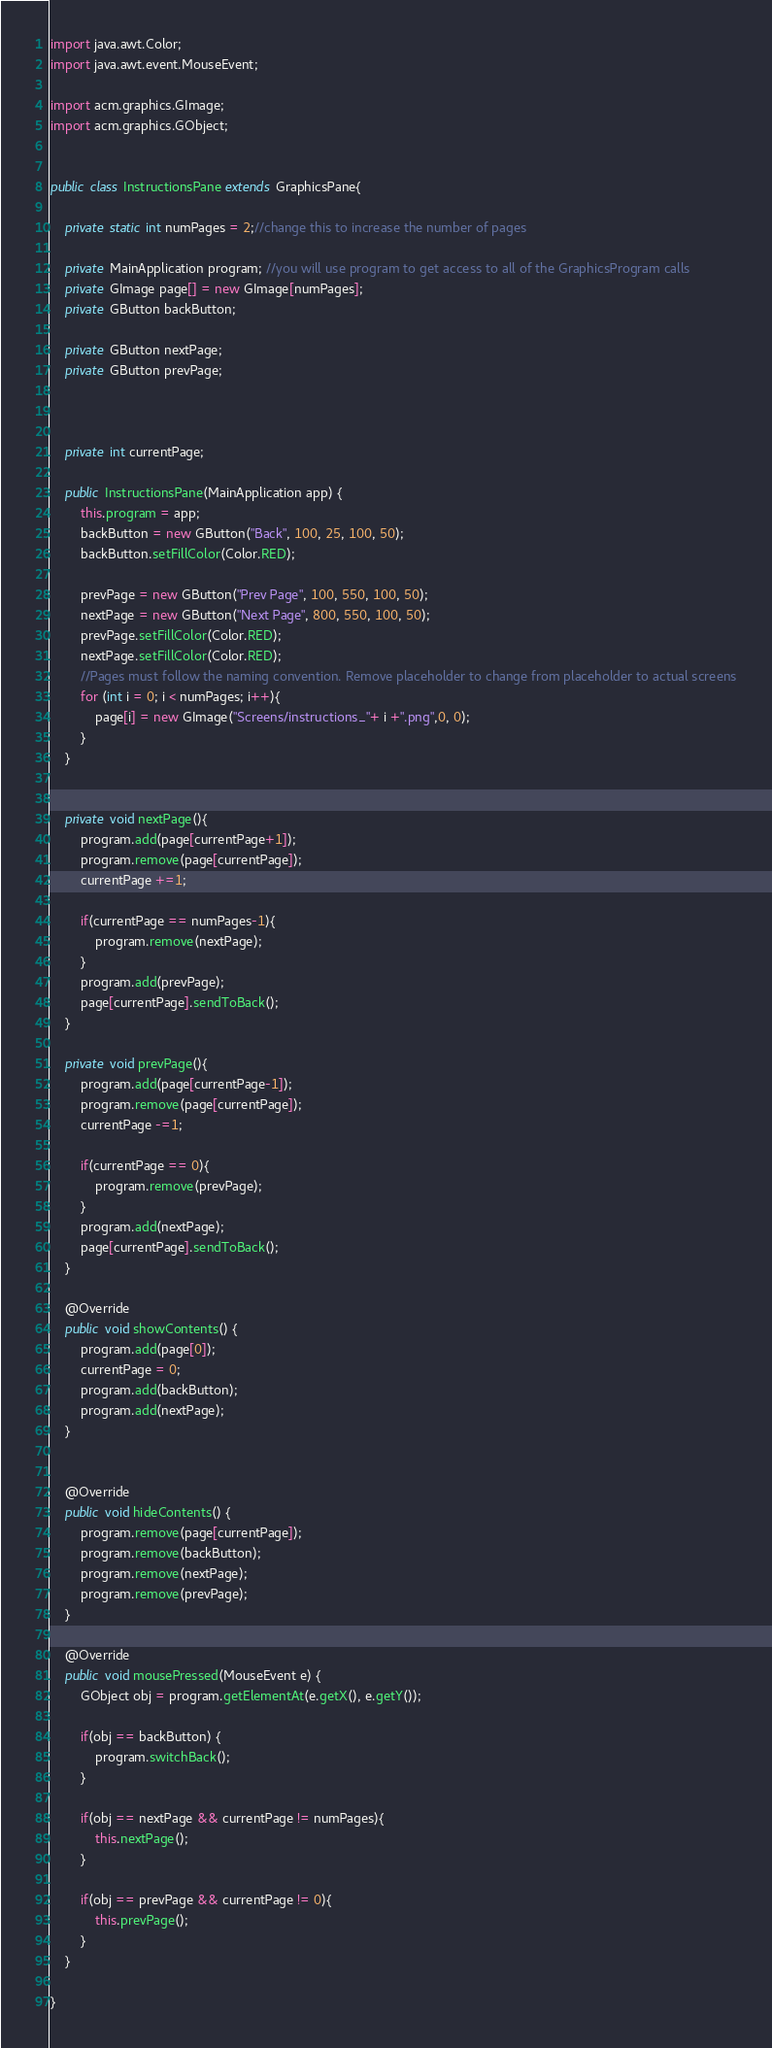Convert code to text. <code><loc_0><loc_0><loc_500><loc_500><_Java_>import java.awt.Color;
import java.awt.event.MouseEvent;

import acm.graphics.GImage;
import acm.graphics.GObject;


public class InstructionsPane extends GraphicsPane{
	
	private static int numPages = 2;//change this to increase the number of pages
	
	private MainApplication program; //you will use program to get access to all of the GraphicsProgram calls
	private GImage page[] = new GImage[numPages];
	private GButton backButton;
	
	private GButton nextPage;
	private GButton prevPage;
	
	
	
	private int currentPage;
	
	public InstructionsPane(MainApplication app) {
		this.program = app;
		backButton = new GButton("Back", 100, 25, 100, 50);
		backButton.setFillColor(Color.RED);
		
		prevPage = new GButton("Prev Page", 100, 550, 100, 50);
		nextPage = new GButton("Next Page", 800, 550, 100, 50);
		prevPage.setFillColor(Color.RED);
		nextPage.setFillColor(Color.RED);
		//Pages must follow the naming convention. Remove placeholder to change from placeholder to actual screens
		for (int i = 0; i < numPages; i++){
			page[i] = new GImage("Screens/instructions_"+ i +".png",0, 0);
		}
	}
	
	
	private void nextPage(){
		program.add(page[currentPage+1]);
		program.remove(page[currentPage]);
		currentPage +=1;
		
		if(currentPage == numPages-1){
			program.remove(nextPage);
		}
		program.add(prevPage);
		page[currentPage].sendToBack();
	}
	
	private void prevPage(){
		program.add(page[currentPage-1]);
		program.remove(page[currentPage]);
		currentPage -=1;
		
		if(currentPage == 0){
			program.remove(prevPage);
		}
		program.add(nextPage);
		page[currentPage].sendToBack();
	}
	
	@Override
	public void showContents() {
		program.add(page[0]);
		currentPage = 0;
		program.add(backButton);
		program.add(nextPage);
	}

	
	@Override
	public void hideContents() {
		program.remove(page[currentPage]);
		program.remove(backButton);
		program.remove(nextPage);
		program.remove(prevPage);
	}
	
	@Override
	public void mousePressed(MouseEvent e) {
		GObject obj = program.getElementAt(e.getX(), e.getY());
		
		if(obj == backButton) {
			program.switchBack();
		}
		
		if(obj == nextPage && currentPage != numPages){
			this.nextPage();
		}
		
		if(obj == prevPage && currentPage != 0){
			this.prevPage();
		}
	}
	
}
</code> 